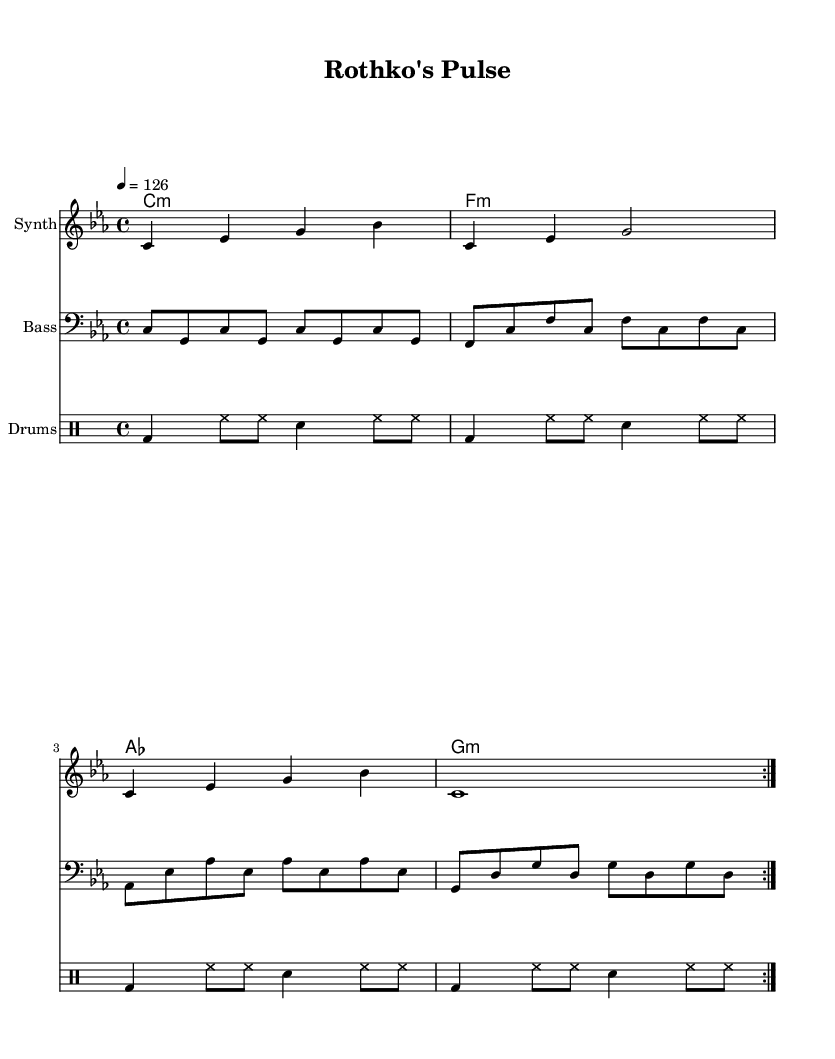What is the key signature of this music? The key signature is C minor, which includes three flats: B flat, E flat, and A flat.
Answer: C minor What is the time signature of this piece? The time signature is 4/4, which indicates four beats per measure and a quarter note gets one beat.
Answer: 4/4 What is the tempo marking specified in the music? The tempo is indicated as "4 = 126," meaning the piece should be played at a speed of 126 quarter notes per minute.
Answer: 126 How many bars are repeated in the synth part? The synth part has two bars that are repeated, as marked by the "repeat volta 2" directive.
Answer: 2 What type of chord is used in the first measure? The chord in the first measure is a C minor chord, as indicated by the chord symbol "c:m."
Answer: C minor Which instrument plays the bass line? The bass line is played by the instrument labeled as "Bass," which is indicated in the music staff.
Answer: Bass How many distinct sections are in the drum part? The drum part consists of a single section that is repeated four times, marked by the "repeat volta 2" directive, making it effectively one unique section.
Answer: 1 